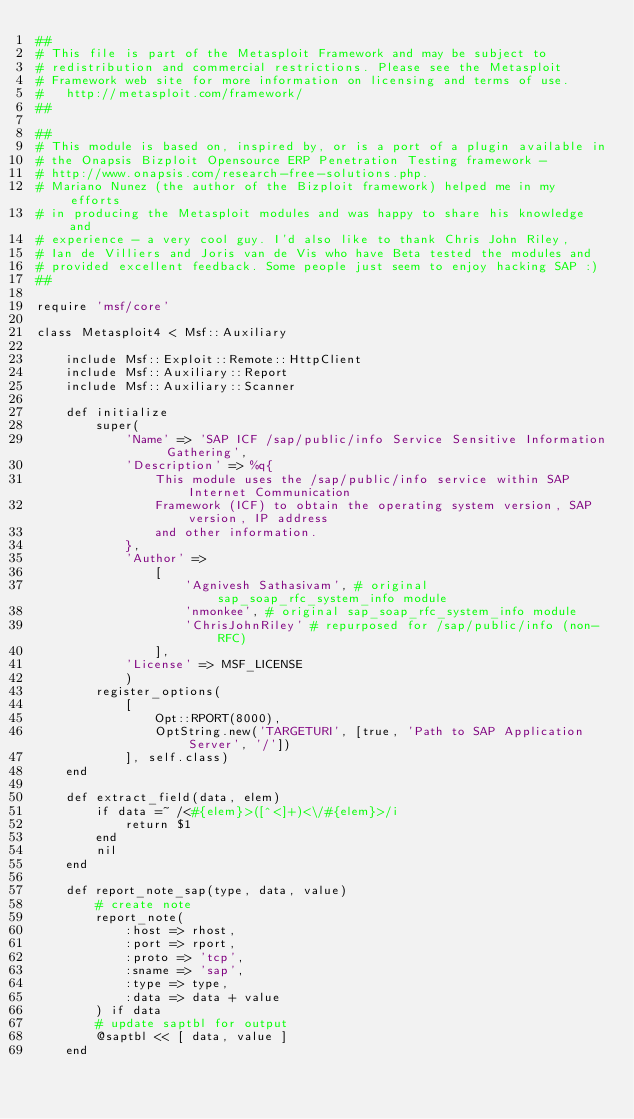Convert code to text. <code><loc_0><loc_0><loc_500><loc_500><_Ruby_>##
# This file is part of the Metasploit Framework and may be subject to
# redistribution and commercial restrictions. Please see the Metasploit
# Framework web site for more information on licensing and terms of use.
#   http://metasploit.com/framework/
##

##
# This module is based on, inspired by, or is a port of a plugin available in
# the Onapsis Bizploit Opensource ERP Penetration Testing framework -
# http://www.onapsis.com/research-free-solutions.php.
# Mariano Nunez (the author of the Bizploit framework) helped me in my efforts
# in producing the Metasploit modules and was happy to share his knowledge and
# experience - a very cool guy. I'd also like to thank Chris John Riley,
# Ian de Villiers and Joris van de Vis who have Beta tested the modules and
# provided excellent feedback. Some people just seem to enjoy hacking SAP :)
##

require 'msf/core'

class Metasploit4 < Msf::Auxiliary

	include Msf::Exploit::Remote::HttpClient
	include Msf::Auxiliary::Report
	include Msf::Auxiliary::Scanner

	def initialize
		super(
			'Name' => 'SAP ICF /sap/public/info Service Sensitive Information Gathering',
			'Description' => %q{
				This module uses the /sap/public/info service within SAP Internet Communication
				Framework (ICF) to obtain the operating system version, SAP version, IP address
				and other information.
			},
			'Author' =>
				[
					'Agnivesh Sathasivam', # original sap_soap_rfc_system_info module
					'nmonkee', # original sap_soap_rfc_system_info module
					'ChrisJohnRiley' # repurposed for /sap/public/info (non-RFC)
				],
			'License' => MSF_LICENSE
			)
		register_options(
			[
				Opt::RPORT(8000),
				OptString.new('TARGETURI', [true, 'Path to SAP Application Server', '/'])
			], self.class)
	end

	def extract_field(data, elem)
		if data =~ /<#{elem}>([^<]+)<\/#{elem}>/i
			return $1
		end
		nil
	end

	def report_note_sap(type, data, value)
		# create note
		report_note(
			:host => rhost,
			:port => rport,
			:proto => 'tcp',
			:sname => 'sap',
			:type => type,
			:data => data + value
		) if data
		# update saptbl for output
		@saptbl << [ data, value ]
	end
</code> 